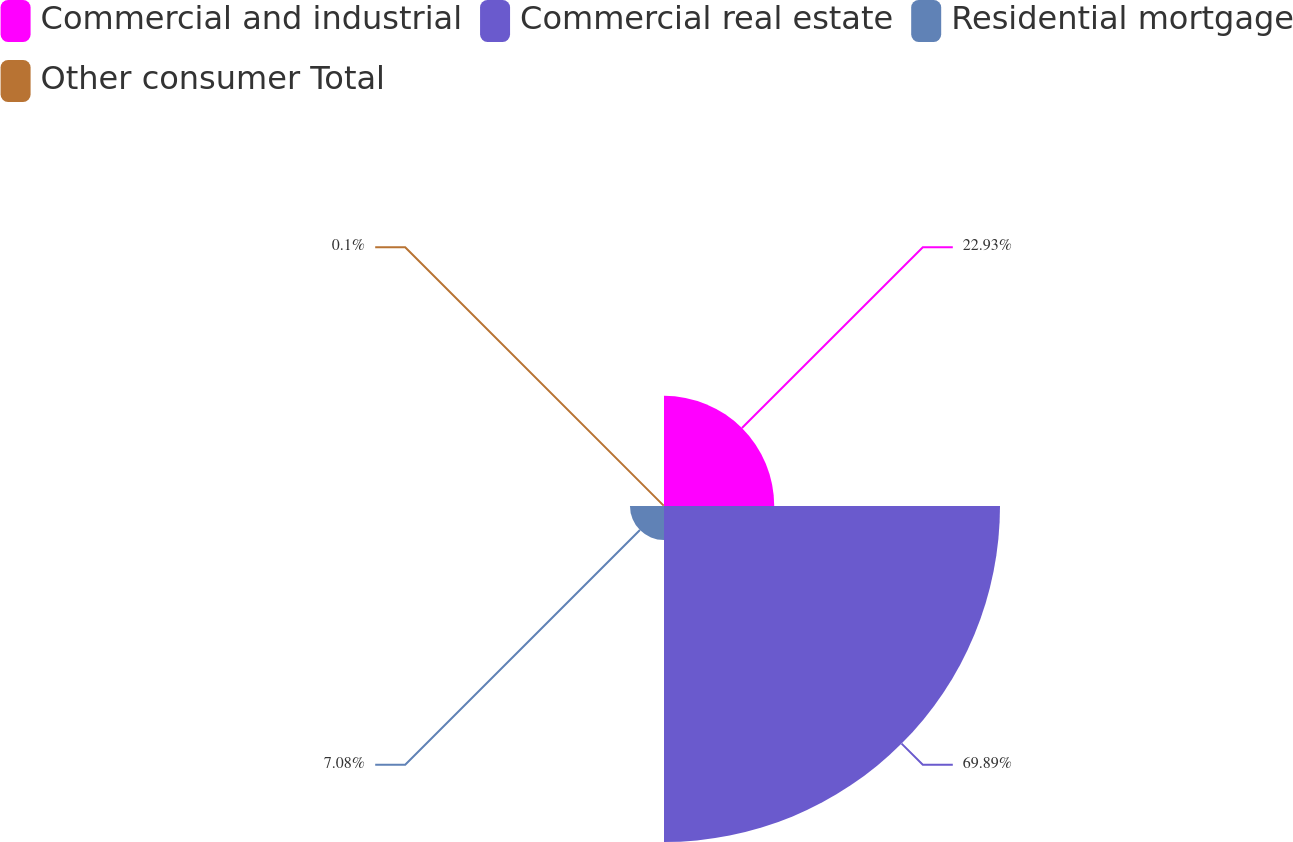Convert chart to OTSL. <chart><loc_0><loc_0><loc_500><loc_500><pie_chart><fcel>Commercial and industrial<fcel>Commercial real estate<fcel>Residential mortgage<fcel>Other consumer Total<nl><fcel>22.93%<fcel>69.9%<fcel>7.08%<fcel>0.1%<nl></chart> 